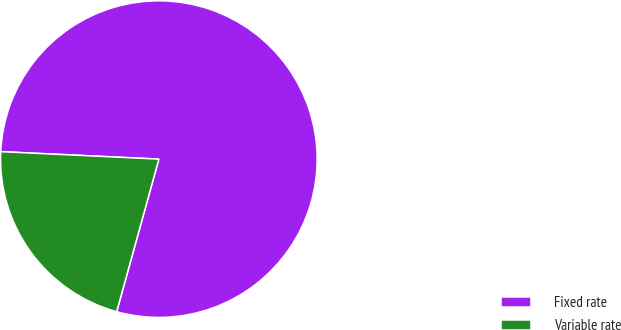Convert chart to OTSL. <chart><loc_0><loc_0><loc_500><loc_500><pie_chart><fcel>Fixed rate<fcel>Variable rate<nl><fcel>78.54%<fcel>21.46%<nl></chart> 